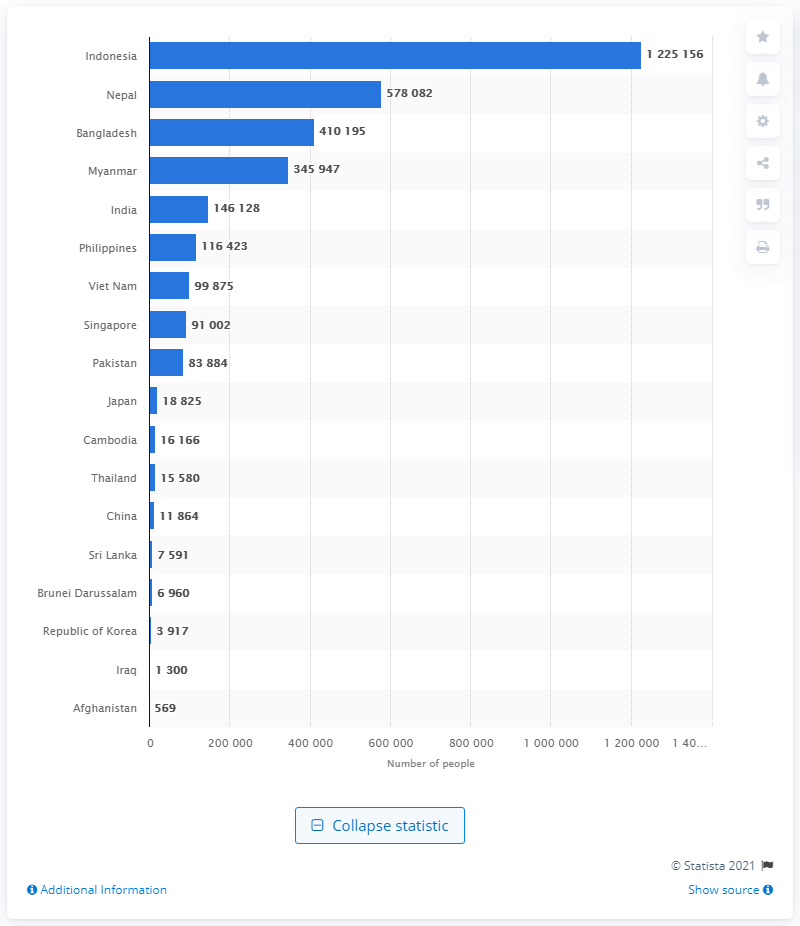List a handful of essential elements in this visual. In Malaysia, there are approximately 12,251,563 Indonesians as of (date). 